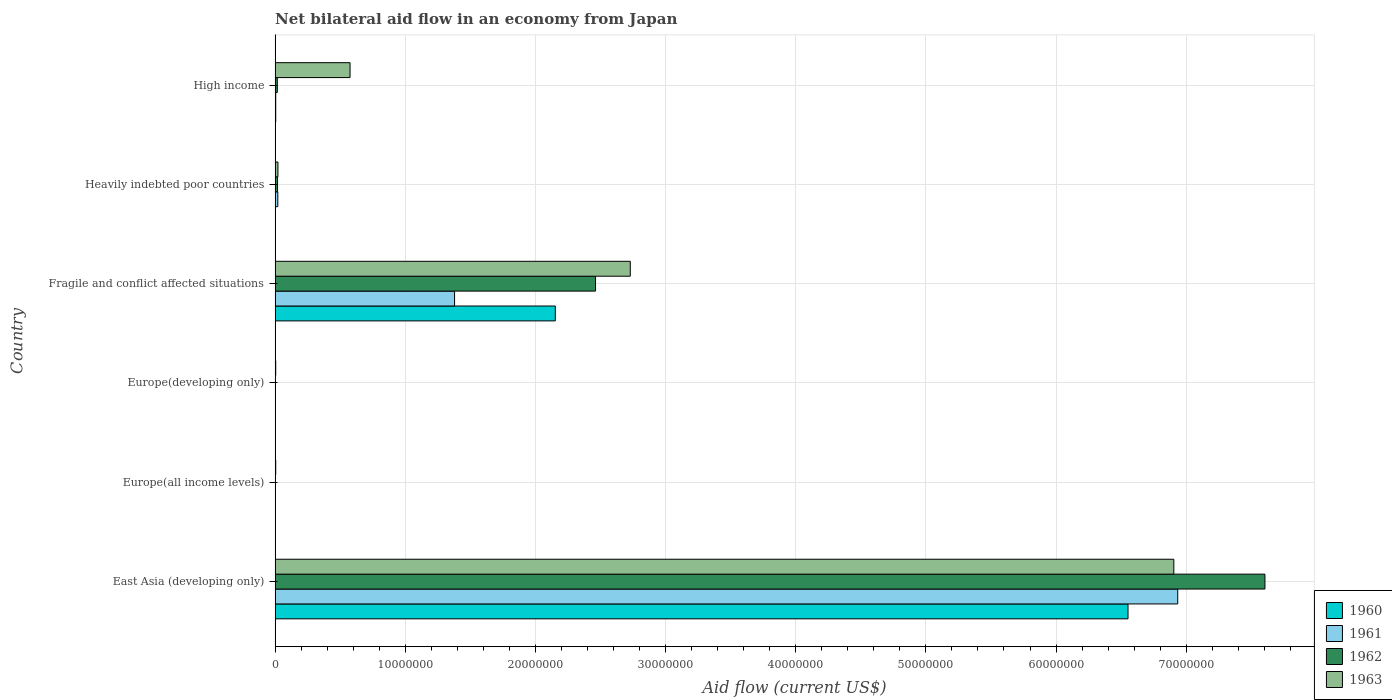Are the number of bars per tick equal to the number of legend labels?
Offer a very short reply. Yes. Are the number of bars on each tick of the Y-axis equal?
Offer a terse response. Yes. How many bars are there on the 2nd tick from the top?
Keep it short and to the point. 4. What is the label of the 3rd group of bars from the top?
Offer a very short reply. Fragile and conflict affected situations. What is the net bilateral aid flow in 1961 in Fragile and conflict affected situations?
Make the answer very short. 1.38e+07. Across all countries, what is the maximum net bilateral aid flow in 1962?
Offer a very short reply. 7.60e+07. In which country was the net bilateral aid flow in 1960 maximum?
Make the answer very short. East Asia (developing only). In which country was the net bilateral aid flow in 1962 minimum?
Your response must be concise. Europe(all income levels). What is the total net bilateral aid flow in 1961 in the graph?
Your answer should be compact. 8.35e+07. What is the difference between the net bilateral aid flow in 1961 in East Asia (developing only) and that in High income?
Provide a succinct answer. 6.93e+07. What is the difference between the net bilateral aid flow in 1961 in Fragile and conflict affected situations and the net bilateral aid flow in 1963 in Europe(all income levels)?
Your response must be concise. 1.37e+07. What is the average net bilateral aid flow in 1961 per country?
Your answer should be very brief. 1.39e+07. What is the difference between the net bilateral aid flow in 1962 and net bilateral aid flow in 1960 in Europe(all income levels)?
Give a very brief answer. 2.00e+04. In how many countries, is the net bilateral aid flow in 1960 greater than 40000000 US$?
Your response must be concise. 1. What is the ratio of the net bilateral aid flow in 1961 in Europe(developing only) to that in Heavily indebted poor countries?
Give a very brief answer. 0.14. Is the difference between the net bilateral aid flow in 1962 in Europe(developing only) and High income greater than the difference between the net bilateral aid flow in 1960 in Europe(developing only) and High income?
Make the answer very short. No. What is the difference between the highest and the second highest net bilateral aid flow in 1962?
Ensure brevity in your answer.  5.14e+07. What is the difference between the highest and the lowest net bilateral aid flow in 1962?
Give a very brief answer. 7.60e+07. Is the sum of the net bilateral aid flow in 1960 in Europe(developing only) and Fragile and conflict affected situations greater than the maximum net bilateral aid flow in 1963 across all countries?
Your answer should be very brief. No. What does the 1st bar from the top in High income represents?
Give a very brief answer. 1963. Is it the case that in every country, the sum of the net bilateral aid flow in 1962 and net bilateral aid flow in 1960 is greater than the net bilateral aid flow in 1961?
Offer a terse response. No. Are all the bars in the graph horizontal?
Your response must be concise. Yes. How many countries are there in the graph?
Make the answer very short. 6. Does the graph contain grids?
Offer a very short reply. Yes. Where does the legend appear in the graph?
Your response must be concise. Bottom right. How many legend labels are there?
Keep it short and to the point. 4. What is the title of the graph?
Offer a terse response. Net bilateral aid flow in an economy from Japan. Does "1982" appear as one of the legend labels in the graph?
Ensure brevity in your answer.  No. What is the Aid flow (current US$) in 1960 in East Asia (developing only)?
Your answer should be compact. 6.55e+07. What is the Aid flow (current US$) of 1961 in East Asia (developing only)?
Make the answer very short. 6.94e+07. What is the Aid flow (current US$) in 1962 in East Asia (developing only)?
Give a very brief answer. 7.60e+07. What is the Aid flow (current US$) in 1963 in East Asia (developing only)?
Offer a very short reply. 6.90e+07. What is the Aid flow (current US$) of 1960 in Europe(all income levels)?
Offer a terse response. 10000. What is the Aid flow (current US$) of 1962 in Europe(all income levels)?
Your answer should be very brief. 3.00e+04. What is the Aid flow (current US$) in 1960 in Fragile and conflict affected situations?
Your response must be concise. 2.15e+07. What is the Aid flow (current US$) of 1961 in Fragile and conflict affected situations?
Keep it short and to the point. 1.38e+07. What is the Aid flow (current US$) of 1962 in Fragile and conflict affected situations?
Your answer should be very brief. 2.46e+07. What is the Aid flow (current US$) in 1963 in Fragile and conflict affected situations?
Ensure brevity in your answer.  2.73e+07. What is the Aid flow (current US$) of 1960 in Heavily indebted poor countries?
Offer a very short reply. 2.00e+04. What is the Aid flow (current US$) of 1961 in Heavily indebted poor countries?
Provide a succinct answer. 2.10e+05. What is the Aid flow (current US$) in 1962 in Heavily indebted poor countries?
Your answer should be compact. 1.90e+05. What is the Aid flow (current US$) of 1963 in Heavily indebted poor countries?
Give a very brief answer. 2.20e+05. What is the Aid flow (current US$) of 1960 in High income?
Keep it short and to the point. 5.00e+04. What is the Aid flow (current US$) in 1962 in High income?
Ensure brevity in your answer.  1.70e+05. What is the Aid flow (current US$) of 1963 in High income?
Make the answer very short. 5.76e+06. Across all countries, what is the maximum Aid flow (current US$) of 1960?
Provide a succinct answer. 6.55e+07. Across all countries, what is the maximum Aid flow (current US$) in 1961?
Offer a terse response. 6.94e+07. Across all countries, what is the maximum Aid flow (current US$) in 1962?
Keep it short and to the point. 7.60e+07. Across all countries, what is the maximum Aid flow (current US$) in 1963?
Your answer should be very brief. 6.90e+07. Across all countries, what is the minimum Aid flow (current US$) of 1963?
Provide a succinct answer. 5.00e+04. What is the total Aid flow (current US$) of 1960 in the graph?
Keep it short and to the point. 8.72e+07. What is the total Aid flow (current US$) in 1961 in the graph?
Ensure brevity in your answer.  8.35e+07. What is the total Aid flow (current US$) in 1962 in the graph?
Your response must be concise. 1.01e+08. What is the total Aid flow (current US$) in 1963 in the graph?
Make the answer very short. 1.02e+08. What is the difference between the Aid flow (current US$) in 1960 in East Asia (developing only) and that in Europe(all income levels)?
Your answer should be compact. 6.55e+07. What is the difference between the Aid flow (current US$) of 1961 in East Asia (developing only) and that in Europe(all income levels)?
Provide a succinct answer. 6.93e+07. What is the difference between the Aid flow (current US$) of 1962 in East Asia (developing only) and that in Europe(all income levels)?
Offer a terse response. 7.60e+07. What is the difference between the Aid flow (current US$) in 1963 in East Asia (developing only) and that in Europe(all income levels)?
Offer a very short reply. 6.90e+07. What is the difference between the Aid flow (current US$) of 1960 in East Asia (developing only) and that in Europe(developing only)?
Ensure brevity in your answer.  6.55e+07. What is the difference between the Aid flow (current US$) of 1961 in East Asia (developing only) and that in Europe(developing only)?
Your response must be concise. 6.93e+07. What is the difference between the Aid flow (current US$) in 1962 in East Asia (developing only) and that in Europe(developing only)?
Provide a short and direct response. 7.60e+07. What is the difference between the Aid flow (current US$) in 1963 in East Asia (developing only) and that in Europe(developing only)?
Your answer should be very brief. 6.90e+07. What is the difference between the Aid flow (current US$) of 1960 in East Asia (developing only) and that in Fragile and conflict affected situations?
Make the answer very short. 4.40e+07. What is the difference between the Aid flow (current US$) of 1961 in East Asia (developing only) and that in Fragile and conflict affected situations?
Give a very brief answer. 5.56e+07. What is the difference between the Aid flow (current US$) of 1962 in East Asia (developing only) and that in Fragile and conflict affected situations?
Provide a short and direct response. 5.14e+07. What is the difference between the Aid flow (current US$) in 1963 in East Asia (developing only) and that in Fragile and conflict affected situations?
Give a very brief answer. 4.18e+07. What is the difference between the Aid flow (current US$) in 1960 in East Asia (developing only) and that in Heavily indebted poor countries?
Provide a succinct answer. 6.55e+07. What is the difference between the Aid flow (current US$) of 1961 in East Asia (developing only) and that in Heavily indebted poor countries?
Ensure brevity in your answer.  6.91e+07. What is the difference between the Aid flow (current US$) in 1962 in East Asia (developing only) and that in Heavily indebted poor countries?
Your response must be concise. 7.59e+07. What is the difference between the Aid flow (current US$) of 1963 in East Asia (developing only) and that in Heavily indebted poor countries?
Keep it short and to the point. 6.88e+07. What is the difference between the Aid flow (current US$) in 1960 in East Asia (developing only) and that in High income?
Make the answer very short. 6.55e+07. What is the difference between the Aid flow (current US$) in 1961 in East Asia (developing only) and that in High income?
Make the answer very short. 6.93e+07. What is the difference between the Aid flow (current US$) in 1962 in East Asia (developing only) and that in High income?
Your response must be concise. 7.59e+07. What is the difference between the Aid flow (current US$) in 1963 in East Asia (developing only) and that in High income?
Offer a very short reply. 6.33e+07. What is the difference between the Aid flow (current US$) in 1960 in Europe(all income levels) and that in Europe(developing only)?
Ensure brevity in your answer.  0. What is the difference between the Aid flow (current US$) in 1961 in Europe(all income levels) and that in Europe(developing only)?
Provide a short and direct response. 0. What is the difference between the Aid flow (current US$) of 1960 in Europe(all income levels) and that in Fragile and conflict affected situations?
Give a very brief answer. -2.15e+07. What is the difference between the Aid flow (current US$) of 1961 in Europe(all income levels) and that in Fragile and conflict affected situations?
Ensure brevity in your answer.  -1.38e+07. What is the difference between the Aid flow (current US$) of 1962 in Europe(all income levels) and that in Fragile and conflict affected situations?
Ensure brevity in your answer.  -2.46e+07. What is the difference between the Aid flow (current US$) of 1963 in Europe(all income levels) and that in Fragile and conflict affected situations?
Offer a terse response. -2.72e+07. What is the difference between the Aid flow (current US$) of 1963 in Europe(all income levels) and that in Heavily indebted poor countries?
Your answer should be compact. -1.70e+05. What is the difference between the Aid flow (current US$) in 1963 in Europe(all income levels) and that in High income?
Give a very brief answer. -5.71e+06. What is the difference between the Aid flow (current US$) of 1960 in Europe(developing only) and that in Fragile and conflict affected situations?
Your answer should be compact. -2.15e+07. What is the difference between the Aid flow (current US$) of 1961 in Europe(developing only) and that in Fragile and conflict affected situations?
Your answer should be very brief. -1.38e+07. What is the difference between the Aid flow (current US$) in 1962 in Europe(developing only) and that in Fragile and conflict affected situations?
Your response must be concise. -2.46e+07. What is the difference between the Aid flow (current US$) in 1963 in Europe(developing only) and that in Fragile and conflict affected situations?
Your answer should be compact. -2.72e+07. What is the difference between the Aid flow (current US$) in 1963 in Europe(developing only) and that in Heavily indebted poor countries?
Keep it short and to the point. -1.70e+05. What is the difference between the Aid flow (current US$) in 1960 in Europe(developing only) and that in High income?
Offer a terse response. -4.00e+04. What is the difference between the Aid flow (current US$) in 1963 in Europe(developing only) and that in High income?
Your answer should be very brief. -5.71e+06. What is the difference between the Aid flow (current US$) of 1960 in Fragile and conflict affected situations and that in Heavily indebted poor countries?
Keep it short and to the point. 2.15e+07. What is the difference between the Aid flow (current US$) of 1961 in Fragile and conflict affected situations and that in Heavily indebted poor countries?
Provide a succinct answer. 1.36e+07. What is the difference between the Aid flow (current US$) in 1962 in Fragile and conflict affected situations and that in Heavily indebted poor countries?
Keep it short and to the point. 2.44e+07. What is the difference between the Aid flow (current US$) in 1963 in Fragile and conflict affected situations and that in Heavily indebted poor countries?
Keep it short and to the point. 2.71e+07. What is the difference between the Aid flow (current US$) of 1960 in Fragile and conflict affected situations and that in High income?
Give a very brief answer. 2.15e+07. What is the difference between the Aid flow (current US$) of 1961 in Fragile and conflict affected situations and that in High income?
Make the answer very short. 1.37e+07. What is the difference between the Aid flow (current US$) of 1962 in Fragile and conflict affected situations and that in High income?
Provide a succinct answer. 2.44e+07. What is the difference between the Aid flow (current US$) in 1963 in Fragile and conflict affected situations and that in High income?
Provide a short and direct response. 2.15e+07. What is the difference between the Aid flow (current US$) of 1960 in Heavily indebted poor countries and that in High income?
Make the answer very short. -3.00e+04. What is the difference between the Aid flow (current US$) in 1961 in Heavily indebted poor countries and that in High income?
Your response must be concise. 1.60e+05. What is the difference between the Aid flow (current US$) in 1962 in Heavily indebted poor countries and that in High income?
Keep it short and to the point. 2.00e+04. What is the difference between the Aid flow (current US$) of 1963 in Heavily indebted poor countries and that in High income?
Offer a very short reply. -5.54e+06. What is the difference between the Aid flow (current US$) of 1960 in East Asia (developing only) and the Aid flow (current US$) of 1961 in Europe(all income levels)?
Make the answer very short. 6.55e+07. What is the difference between the Aid flow (current US$) in 1960 in East Asia (developing only) and the Aid flow (current US$) in 1962 in Europe(all income levels)?
Your response must be concise. 6.55e+07. What is the difference between the Aid flow (current US$) of 1960 in East Asia (developing only) and the Aid flow (current US$) of 1963 in Europe(all income levels)?
Your answer should be compact. 6.55e+07. What is the difference between the Aid flow (current US$) in 1961 in East Asia (developing only) and the Aid flow (current US$) in 1962 in Europe(all income levels)?
Ensure brevity in your answer.  6.93e+07. What is the difference between the Aid flow (current US$) in 1961 in East Asia (developing only) and the Aid flow (current US$) in 1963 in Europe(all income levels)?
Give a very brief answer. 6.93e+07. What is the difference between the Aid flow (current US$) of 1962 in East Asia (developing only) and the Aid flow (current US$) of 1963 in Europe(all income levels)?
Provide a succinct answer. 7.60e+07. What is the difference between the Aid flow (current US$) of 1960 in East Asia (developing only) and the Aid flow (current US$) of 1961 in Europe(developing only)?
Your answer should be very brief. 6.55e+07. What is the difference between the Aid flow (current US$) of 1960 in East Asia (developing only) and the Aid flow (current US$) of 1962 in Europe(developing only)?
Keep it short and to the point. 6.55e+07. What is the difference between the Aid flow (current US$) in 1960 in East Asia (developing only) and the Aid flow (current US$) in 1963 in Europe(developing only)?
Make the answer very short. 6.55e+07. What is the difference between the Aid flow (current US$) in 1961 in East Asia (developing only) and the Aid flow (current US$) in 1962 in Europe(developing only)?
Provide a short and direct response. 6.93e+07. What is the difference between the Aid flow (current US$) in 1961 in East Asia (developing only) and the Aid flow (current US$) in 1963 in Europe(developing only)?
Your answer should be very brief. 6.93e+07. What is the difference between the Aid flow (current US$) of 1962 in East Asia (developing only) and the Aid flow (current US$) of 1963 in Europe(developing only)?
Keep it short and to the point. 7.60e+07. What is the difference between the Aid flow (current US$) in 1960 in East Asia (developing only) and the Aid flow (current US$) in 1961 in Fragile and conflict affected situations?
Ensure brevity in your answer.  5.17e+07. What is the difference between the Aid flow (current US$) of 1960 in East Asia (developing only) and the Aid flow (current US$) of 1962 in Fragile and conflict affected situations?
Your answer should be very brief. 4.09e+07. What is the difference between the Aid flow (current US$) in 1960 in East Asia (developing only) and the Aid flow (current US$) in 1963 in Fragile and conflict affected situations?
Your answer should be very brief. 3.82e+07. What is the difference between the Aid flow (current US$) of 1961 in East Asia (developing only) and the Aid flow (current US$) of 1962 in Fragile and conflict affected situations?
Give a very brief answer. 4.47e+07. What is the difference between the Aid flow (current US$) in 1961 in East Asia (developing only) and the Aid flow (current US$) in 1963 in Fragile and conflict affected situations?
Your answer should be compact. 4.21e+07. What is the difference between the Aid flow (current US$) of 1962 in East Asia (developing only) and the Aid flow (current US$) of 1963 in Fragile and conflict affected situations?
Your response must be concise. 4.88e+07. What is the difference between the Aid flow (current US$) in 1960 in East Asia (developing only) and the Aid flow (current US$) in 1961 in Heavily indebted poor countries?
Give a very brief answer. 6.53e+07. What is the difference between the Aid flow (current US$) in 1960 in East Asia (developing only) and the Aid flow (current US$) in 1962 in Heavily indebted poor countries?
Provide a short and direct response. 6.53e+07. What is the difference between the Aid flow (current US$) in 1960 in East Asia (developing only) and the Aid flow (current US$) in 1963 in Heavily indebted poor countries?
Offer a very short reply. 6.53e+07. What is the difference between the Aid flow (current US$) of 1961 in East Asia (developing only) and the Aid flow (current US$) of 1962 in Heavily indebted poor countries?
Provide a succinct answer. 6.92e+07. What is the difference between the Aid flow (current US$) in 1961 in East Asia (developing only) and the Aid flow (current US$) in 1963 in Heavily indebted poor countries?
Ensure brevity in your answer.  6.91e+07. What is the difference between the Aid flow (current US$) in 1962 in East Asia (developing only) and the Aid flow (current US$) in 1963 in Heavily indebted poor countries?
Your response must be concise. 7.58e+07. What is the difference between the Aid flow (current US$) in 1960 in East Asia (developing only) and the Aid flow (current US$) in 1961 in High income?
Your response must be concise. 6.55e+07. What is the difference between the Aid flow (current US$) of 1960 in East Asia (developing only) and the Aid flow (current US$) of 1962 in High income?
Offer a very short reply. 6.54e+07. What is the difference between the Aid flow (current US$) of 1960 in East Asia (developing only) and the Aid flow (current US$) of 1963 in High income?
Your response must be concise. 5.98e+07. What is the difference between the Aid flow (current US$) in 1961 in East Asia (developing only) and the Aid flow (current US$) in 1962 in High income?
Your response must be concise. 6.92e+07. What is the difference between the Aid flow (current US$) in 1961 in East Asia (developing only) and the Aid flow (current US$) in 1963 in High income?
Make the answer very short. 6.36e+07. What is the difference between the Aid flow (current US$) of 1962 in East Asia (developing only) and the Aid flow (current US$) of 1963 in High income?
Your answer should be compact. 7.03e+07. What is the difference between the Aid flow (current US$) in 1960 in Europe(all income levels) and the Aid flow (current US$) in 1963 in Europe(developing only)?
Ensure brevity in your answer.  -4.00e+04. What is the difference between the Aid flow (current US$) in 1961 in Europe(all income levels) and the Aid flow (current US$) in 1962 in Europe(developing only)?
Give a very brief answer. 0. What is the difference between the Aid flow (current US$) in 1961 in Europe(all income levels) and the Aid flow (current US$) in 1963 in Europe(developing only)?
Ensure brevity in your answer.  -2.00e+04. What is the difference between the Aid flow (current US$) of 1962 in Europe(all income levels) and the Aid flow (current US$) of 1963 in Europe(developing only)?
Provide a succinct answer. -2.00e+04. What is the difference between the Aid flow (current US$) of 1960 in Europe(all income levels) and the Aid flow (current US$) of 1961 in Fragile and conflict affected situations?
Keep it short and to the point. -1.38e+07. What is the difference between the Aid flow (current US$) of 1960 in Europe(all income levels) and the Aid flow (current US$) of 1962 in Fragile and conflict affected situations?
Your answer should be compact. -2.46e+07. What is the difference between the Aid flow (current US$) in 1960 in Europe(all income levels) and the Aid flow (current US$) in 1963 in Fragile and conflict affected situations?
Your response must be concise. -2.73e+07. What is the difference between the Aid flow (current US$) of 1961 in Europe(all income levels) and the Aid flow (current US$) of 1962 in Fragile and conflict affected situations?
Ensure brevity in your answer.  -2.46e+07. What is the difference between the Aid flow (current US$) of 1961 in Europe(all income levels) and the Aid flow (current US$) of 1963 in Fragile and conflict affected situations?
Provide a short and direct response. -2.73e+07. What is the difference between the Aid flow (current US$) of 1962 in Europe(all income levels) and the Aid flow (current US$) of 1963 in Fragile and conflict affected situations?
Make the answer very short. -2.73e+07. What is the difference between the Aid flow (current US$) of 1960 in Europe(all income levels) and the Aid flow (current US$) of 1962 in Heavily indebted poor countries?
Provide a succinct answer. -1.80e+05. What is the difference between the Aid flow (current US$) of 1960 in Europe(all income levels) and the Aid flow (current US$) of 1963 in Heavily indebted poor countries?
Make the answer very short. -2.10e+05. What is the difference between the Aid flow (current US$) in 1962 in Europe(all income levels) and the Aid flow (current US$) in 1963 in Heavily indebted poor countries?
Provide a short and direct response. -1.90e+05. What is the difference between the Aid flow (current US$) in 1960 in Europe(all income levels) and the Aid flow (current US$) in 1961 in High income?
Your response must be concise. -4.00e+04. What is the difference between the Aid flow (current US$) of 1960 in Europe(all income levels) and the Aid flow (current US$) of 1962 in High income?
Your answer should be compact. -1.60e+05. What is the difference between the Aid flow (current US$) in 1960 in Europe(all income levels) and the Aid flow (current US$) in 1963 in High income?
Provide a short and direct response. -5.75e+06. What is the difference between the Aid flow (current US$) of 1961 in Europe(all income levels) and the Aid flow (current US$) of 1962 in High income?
Keep it short and to the point. -1.40e+05. What is the difference between the Aid flow (current US$) in 1961 in Europe(all income levels) and the Aid flow (current US$) in 1963 in High income?
Give a very brief answer. -5.73e+06. What is the difference between the Aid flow (current US$) of 1962 in Europe(all income levels) and the Aid flow (current US$) of 1963 in High income?
Your answer should be very brief. -5.73e+06. What is the difference between the Aid flow (current US$) of 1960 in Europe(developing only) and the Aid flow (current US$) of 1961 in Fragile and conflict affected situations?
Offer a terse response. -1.38e+07. What is the difference between the Aid flow (current US$) of 1960 in Europe(developing only) and the Aid flow (current US$) of 1962 in Fragile and conflict affected situations?
Provide a succinct answer. -2.46e+07. What is the difference between the Aid flow (current US$) in 1960 in Europe(developing only) and the Aid flow (current US$) in 1963 in Fragile and conflict affected situations?
Offer a very short reply. -2.73e+07. What is the difference between the Aid flow (current US$) of 1961 in Europe(developing only) and the Aid flow (current US$) of 1962 in Fragile and conflict affected situations?
Your answer should be very brief. -2.46e+07. What is the difference between the Aid flow (current US$) in 1961 in Europe(developing only) and the Aid flow (current US$) in 1963 in Fragile and conflict affected situations?
Offer a very short reply. -2.73e+07. What is the difference between the Aid flow (current US$) of 1962 in Europe(developing only) and the Aid flow (current US$) of 1963 in Fragile and conflict affected situations?
Give a very brief answer. -2.73e+07. What is the difference between the Aid flow (current US$) of 1960 in Europe(developing only) and the Aid flow (current US$) of 1961 in Heavily indebted poor countries?
Your answer should be compact. -2.00e+05. What is the difference between the Aid flow (current US$) in 1960 in Europe(developing only) and the Aid flow (current US$) in 1962 in Heavily indebted poor countries?
Offer a terse response. -1.80e+05. What is the difference between the Aid flow (current US$) of 1960 in Europe(developing only) and the Aid flow (current US$) of 1963 in Heavily indebted poor countries?
Ensure brevity in your answer.  -2.10e+05. What is the difference between the Aid flow (current US$) in 1962 in Europe(developing only) and the Aid flow (current US$) in 1963 in Heavily indebted poor countries?
Keep it short and to the point. -1.90e+05. What is the difference between the Aid flow (current US$) of 1960 in Europe(developing only) and the Aid flow (current US$) of 1963 in High income?
Your answer should be very brief. -5.75e+06. What is the difference between the Aid flow (current US$) in 1961 in Europe(developing only) and the Aid flow (current US$) in 1962 in High income?
Offer a terse response. -1.40e+05. What is the difference between the Aid flow (current US$) in 1961 in Europe(developing only) and the Aid flow (current US$) in 1963 in High income?
Your answer should be compact. -5.73e+06. What is the difference between the Aid flow (current US$) in 1962 in Europe(developing only) and the Aid flow (current US$) in 1963 in High income?
Give a very brief answer. -5.73e+06. What is the difference between the Aid flow (current US$) of 1960 in Fragile and conflict affected situations and the Aid flow (current US$) of 1961 in Heavily indebted poor countries?
Provide a short and direct response. 2.13e+07. What is the difference between the Aid flow (current US$) in 1960 in Fragile and conflict affected situations and the Aid flow (current US$) in 1962 in Heavily indebted poor countries?
Make the answer very short. 2.13e+07. What is the difference between the Aid flow (current US$) of 1960 in Fragile and conflict affected situations and the Aid flow (current US$) of 1963 in Heavily indebted poor countries?
Offer a terse response. 2.13e+07. What is the difference between the Aid flow (current US$) of 1961 in Fragile and conflict affected situations and the Aid flow (current US$) of 1962 in Heavily indebted poor countries?
Provide a short and direct response. 1.36e+07. What is the difference between the Aid flow (current US$) of 1961 in Fragile and conflict affected situations and the Aid flow (current US$) of 1963 in Heavily indebted poor countries?
Offer a terse response. 1.36e+07. What is the difference between the Aid flow (current US$) in 1962 in Fragile and conflict affected situations and the Aid flow (current US$) in 1963 in Heavily indebted poor countries?
Keep it short and to the point. 2.44e+07. What is the difference between the Aid flow (current US$) of 1960 in Fragile and conflict affected situations and the Aid flow (current US$) of 1961 in High income?
Offer a very short reply. 2.15e+07. What is the difference between the Aid flow (current US$) of 1960 in Fragile and conflict affected situations and the Aid flow (current US$) of 1962 in High income?
Keep it short and to the point. 2.14e+07. What is the difference between the Aid flow (current US$) in 1960 in Fragile and conflict affected situations and the Aid flow (current US$) in 1963 in High income?
Give a very brief answer. 1.58e+07. What is the difference between the Aid flow (current US$) in 1961 in Fragile and conflict affected situations and the Aid flow (current US$) in 1962 in High income?
Your response must be concise. 1.36e+07. What is the difference between the Aid flow (current US$) of 1961 in Fragile and conflict affected situations and the Aid flow (current US$) of 1963 in High income?
Keep it short and to the point. 8.03e+06. What is the difference between the Aid flow (current US$) of 1962 in Fragile and conflict affected situations and the Aid flow (current US$) of 1963 in High income?
Give a very brief answer. 1.89e+07. What is the difference between the Aid flow (current US$) in 1960 in Heavily indebted poor countries and the Aid flow (current US$) in 1963 in High income?
Ensure brevity in your answer.  -5.74e+06. What is the difference between the Aid flow (current US$) of 1961 in Heavily indebted poor countries and the Aid flow (current US$) of 1963 in High income?
Provide a succinct answer. -5.55e+06. What is the difference between the Aid flow (current US$) of 1962 in Heavily indebted poor countries and the Aid flow (current US$) of 1963 in High income?
Your answer should be compact. -5.57e+06. What is the average Aid flow (current US$) in 1960 per country?
Ensure brevity in your answer.  1.45e+07. What is the average Aid flow (current US$) of 1961 per country?
Ensure brevity in your answer.  1.39e+07. What is the average Aid flow (current US$) in 1962 per country?
Your response must be concise. 1.68e+07. What is the average Aid flow (current US$) in 1963 per country?
Give a very brief answer. 1.71e+07. What is the difference between the Aid flow (current US$) of 1960 and Aid flow (current US$) of 1961 in East Asia (developing only)?
Give a very brief answer. -3.82e+06. What is the difference between the Aid flow (current US$) in 1960 and Aid flow (current US$) in 1962 in East Asia (developing only)?
Ensure brevity in your answer.  -1.05e+07. What is the difference between the Aid flow (current US$) in 1960 and Aid flow (current US$) in 1963 in East Asia (developing only)?
Offer a terse response. -3.52e+06. What is the difference between the Aid flow (current US$) in 1961 and Aid flow (current US$) in 1962 in East Asia (developing only)?
Your response must be concise. -6.70e+06. What is the difference between the Aid flow (current US$) of 1961 and Aid flow (current US$) of 1962 in Europe(all income levels)?
Your response must be concise. 0. What is the difference between the Aid flow (current US$) of 1961 and Aid flow (current US$) of 1963 in Europe(all income levels)?
Provide a short and direct response. -2.00e+04. What is the difference between the Aid flow (current US$) of 1962 and Aid flow (current US$) of 1963 in Europe(all income levels)?
Ensure brevity in your answer.  -2.00e+04. What is the difference between the Aid flow (current US$) in 1960 and Aid flow (current US$) in 1961 in Europe(developing only)?
Make the answer very short. -2.00e+04. What is the difference between the Aid flow (current US$) of 1960 and Aid flow (current US$) of 1962 in Europe(developing only)?
Your answer should be very brief. -2.00e+04. What is the difference between the Aid flow (current US$) in 1961 and Aid flow (current US$) in 1963 in Europe(developing only)?
Your answer should be compact. -2.00e+04. What is the difference between the Aid flow (current US$) in 1962 and Aid flow (current US$) in 1963 in Europe(developing only)?
Provide a short and direct response. -2.00e+04. What is the difference between the Aid flow (current US$) in 1960 and Aid flow (current US$) in 1961 in Fragile and conflict affected situations?
Keep it short and to the point. 7.74e+06. What is the difference between the Aid flow (current US$) of 1960 and Aid flow (current US$) of 1962 in Fragile and conflict affected situations?
Offer a very short reply. -3.09e+06. What is the difference between the Aid flow (current US$) of 1960 and Aid flow (current US$) of 1963 in Fragile and conflict affected situations?
Give a very brief answer. -5.76e+06. What is the difference between the Aid flow (current US$) of 1961 and Aid flow (current US$) of 1962 in Fragile and conflict affected situations?
Offer a very short reply. -1.08e+07. What is the difference between the Aid flow (current US$) of 1961 and Aid flow (current US$) of 1963 in Fragile and conflict affected situations?
Your answer should be very brief. -1.35e+07. What is the difference between the Aid flow (current US$) in 1962 and Aid flow (current US$) in 1963 in Fragile and conflict affected situations?
Keep it short and to the point. -2.67e+06. What is the difference between the Aid flow (current US$) in 1960 and Aid flow (current US$) in 1961 in Heavily indebted poor countries?
Give a very brief answer. -1.90e+05. What is the difference between the Aid flow (current US$) of 1962 and Aid flow (current US$) of 1963 in Heavily indebted poor countries?
Your answer should be very brief. -3.00e+04. What is the difference between the Aid flow (current US$) of 1960 and Aid flow (current US$) of 1961 in High income?
Provide a short and direct response. 0. What is the difference between the Aid flow (current US$) in 1960 and Aid flow (current US$) in 1963 in High income?
Ensure brevity in your answer.  -5.71e+06. What is the difference between the Aid flow (current US$) of 1961 and Aid flow (current US$) of 1963 in High income?
Your answer should be very brief. -5.71e+06. What is the difference between the Aid flow (current US$) of 1962 and Aid flow (current US$) of 1963 in High income?
Make the answer very short. -5.59e+06. What is the ratio of the Aid flow (current US$) in 1960 in East Asia (developing only) to that in Europe(all income levels)?
Offer a terse response. 6553. What is the ratio of the Aid flow (current US$) of 1961 in East Asia (developing only) to that in Europe(all income levels)?
Ensure brevity in your answer.  2311.67. What is the ratio of the Aid flow (current US$) of 1962 in East Asia (developing only) to that in Europe(all income levels)?
Ensure brevity in your answer.  2535. What is the ratio of the Aid flow (current US$) of 1963 in East Asia (developing only) to that in Europe(all income levels)?
Keep it short and to the point. 1381. What is the ratio of the Aid flow (current US$) of 1960 in East Asia (developing only) to that in Europe(developing only)?
Offer a very short reply. 6553. What is the ratio of the Aid flow (current US$) of 1961 in East Asia (developing only) to that in Europe(developing only)?
Your answer should be compact. 2311.67. What is the ratio of the Aid flow (current US$) in 1962 in East Asia (developing only) to that in Europe(developing only)?
Make the answer very short. 2535. What is the ratio of the Aid flow (current US$) in 1963 in East Asia (developing only) to that in Europe(developing only)?
Provide a short and direct response. 1381. What is the ratio of the Aid flow (current US$) in 1960 in East Asia (developing only) to that in Fragile and conflict affected situations?
Your response must be concise. 3.04. What is the ratio of the Aid flow (current US$) in 1961 in East Asia (developing only) to that in Fragile and conflict affected situations?
Provide a short and direct response. 5.03. What is the ratio of the Aid flow (current US$) in 1962 in East Asia (developing only) to that in Fragile and conflict affected situations?
Offer a very short reply. 3.09. What is the ratio of the Aid flow (current US$) of 1963 in East Asia (developing only) to that in Fragile and conflict affected situations?
Make the answer very short. 2.53. What is the ratio of the Aid flow (current US$) in 1960 in East Asia (developing only) to that in Heavily indebted poor countries?
Provide a short and direct response. 3276.5. What is the ratio of the Aid flow (current US$) of 1961 in East Asia (developing only) to that in Heavily indebted poor countries?
Offer a very short reply. 330.24. What is the ratio of the Aid flow (current US$) in 1962 in East Asia (developing only) to that in Heavily indebted poor countries?
Provide a succinct answer. 400.26. What is the ratio of the Aid flow (current US$) of 1963 in East Asia (developing only) to that in Heavily indebted poor countries?
Your response must be concise. 313.86. What is the ratio of the Aid flow (current US$) of 1960 in East Asia (developing only) to that in High income?
Your answer should be very brief. 1310.6. What is the ratio of the Aid flow (current US$) in 1961 in East Asia (developing only) to that in High income?
Give a very brief answer. 1387. What is the ratio of the Aid flow (current US$) in 1962 in East Asia (developing only) to that in High income?
Provide a succinct answer. 447.35. What is the ratio of the Aid flow (current US$) in 1963 in East Asia (developing only) to that in High income?
Keep it short and to the point. 11.99. What is the ratio of the Aid flow (current US$) in 1960 in Europe(all income levels) to that in Europe(developing only)?
Ensure brevity in your answer.  1. What is the ratio of the Aid flow (current US$) in 1962 in Europe(all income levels) to that in Europe(developing only)?
Give a very brief answer. 1. What is the ratio of the Aid flow (current US$) of 1961 in Europe(all income levels) to that in Fragile and conflict affected situations?
Make the answer very short. 0. What is the ratio of the Aid flow (current US$) of 1962 in Europe(all income levels) to that in Fragile and conflict affected situations?
Your answer should be compact. 0. What is the ratio of the Aid flow (current US$) of 1963 in Europe(all income levels) to that in Fragile and conflict affected situations?
Provide a succinct answer. 0. What is the ratio of the Aid flow (current US$) of 1960 in Europe(all income levels) to that in Heavily indebted poor countries?
Your response must be concise. 0.5. What is the ratio of the Aid flow (current US$) in 1961 in Europe(all income levels) to that in Heavily indebted poor countries?
Provide a succinct answer. 0.14. What is the ratio of the Aid flow (current US$) in 1962 in Europe(all income levels) to that in Heavily indebted poor countries?
Make the answer very short. 0.16. What is the ratio of the Aid flow (current US$) in 1963 in Europe(all income levels) to that in Heavily indebted poor countries?
Make the answer very short. 0.23. What is the ratio of the Aid flow (current US$) of 1960 in Europe(all income levels) to that in High income?
Ensure brevity in your answer.  0.2. What is the ratio of the Aid flow (current US$) in 1962 in Europe(all income levels) to that in High income?
Give a very brief answer. 0.18. What is the ratio of the Aid flow (current US$) in 1963 in Europe(all income levels) to that in High income?
Your answer should be compact. 0.01. What is the ratio of the Aid flow (current US$) of 1960 in Europe(developing only) to that in Fragile and conflict affected situations?
Offer a terse response. 0. What is the ratio of the Aid flow (current US$) of 1961 in Europe(developing only) to that in Fragile and conflict affected situations?
Offer a terse response. 0. What is the ratio of the Aid flow (current US$) of 1962 in Europe(developing only) to that in Fragile and conflict affected situations?
Your answer should be very brief. 0. What is the ratio of the Aid flow (current US$) of 1963 in Europe(developing only) to that in Fragile and conflict affected situations?
Make the answer very short. 0. What is the ratio of the Aid flow (current US$) in 1961 in Europe(developing only) to that in Heavily indebted poor countries?
Ensure brevity in your answer.  0.14. What is the ratio of the Aid flow (current US$) of 1962 in Europe(developing only) to that in Heavily indebted poor countries?
Your answer should be very brief. 0.16. What is the ratio of the Aid flow (current US$) of 1963 in Europe(developing only) to that in Heavily indebted poor countries?
Make the answer very short. 0.23. What is the ratio of the Aid flow (current US$) of 1961 in Europe(developing only) to that in High income?
Make the answer very short. 0.6. What is the ratio of the Aid flow (current US$) in 1962 in Europe(developing only) to that in High income?
Offer a terse response. 0.18. What is the ratio of the Aid flow (current US$) in 1963 in Europe(developing only) to that in High income?
Give a very brief answer. 0.01. What is the ratio of the Aid flow (current US$) in 1960 in Fragile and conflict affected situations to that in Heavily indebted poor countries?
Ensure brevity in your answer.  1076.5. What is the ratio of the Aid flow (current US$) of 1961 in Fragile and conflict affected situations to that in Heavily indebted poor countries?
Offer a very short reply. 65.67. What is the ratio of the Aid flow (current US$) of 1962 in Fragile and conflict affected situations to that in Heavily indebted poor countries?
Your answer should be compact. 129.58. What is the ratio of the Aid flow (current US$) of 1963 in Fragile and conflict affected situations to that in Heavily indebted poor countries?
Offer a terse response. 124.05. What is the ratio of the Aid flow (current US$) of 1960 in Fragile and conflict affected situations to that in High income?
Your response must be concise. 430.6. What is the ratio of the Aid flow (current US$) in 1961 in Fragile and conflict affected situations to that in High income?
Offer a terse response. 275.8. What is the ratio of the Aid flow (current US$) in 1962 in Fragile and conflict affected situations to that in High income?
Provide a succinct answer. 144.82. What is the ratio of the Aid flow (current US$) of 1963 in Fragile and conflict affected situations to that in High income?
Provide a short and direct response. 4.74. What is the ratio of the Aid flow (current US$) of 1962 in Heavily indebted poor countries to that in High income?
Provide a short and direct response. 1.12. What is the ratio of the Aid flow (current US$) in 1963 in Heavily indebted poor countries to that in High income?
Give a very brief answer. 0.04. What is the difference between the highest and the second highest Aid flow (current US$) in 1960?
Your answer should be compact. 4.40e+07. What is the difference between the highest and the second highest Aid flow (current US$) of 1961?
Your answer should be very brief. 5.56e+07. What is the difference between the highest and the second highest Aid flow (current US$) of 1962?
Provide a succinct answer. 5.14e+07. What is the difference between the highest and the second highest Aid flow (current US$) in 1963?
Give a very brief answer. 4.18e+07. What is the difference between the highest and the lowest Aid flow (current US$) of 1960?
Your answer should be very brief. 6.55e+07. What is the difference between the highest and the lowest Aid flow (current US$) in 1961?
Offer a terse response. 6.93e+07. What is the difference between the highest and the lowest Aid flow (current US$) in 1962?
Your answer should be very brief. 7.60e+07. What is the difference between the highest and the lowest Aid flow (current US$) of 1963?
Keep it short and to the point. 6.90e+07. 